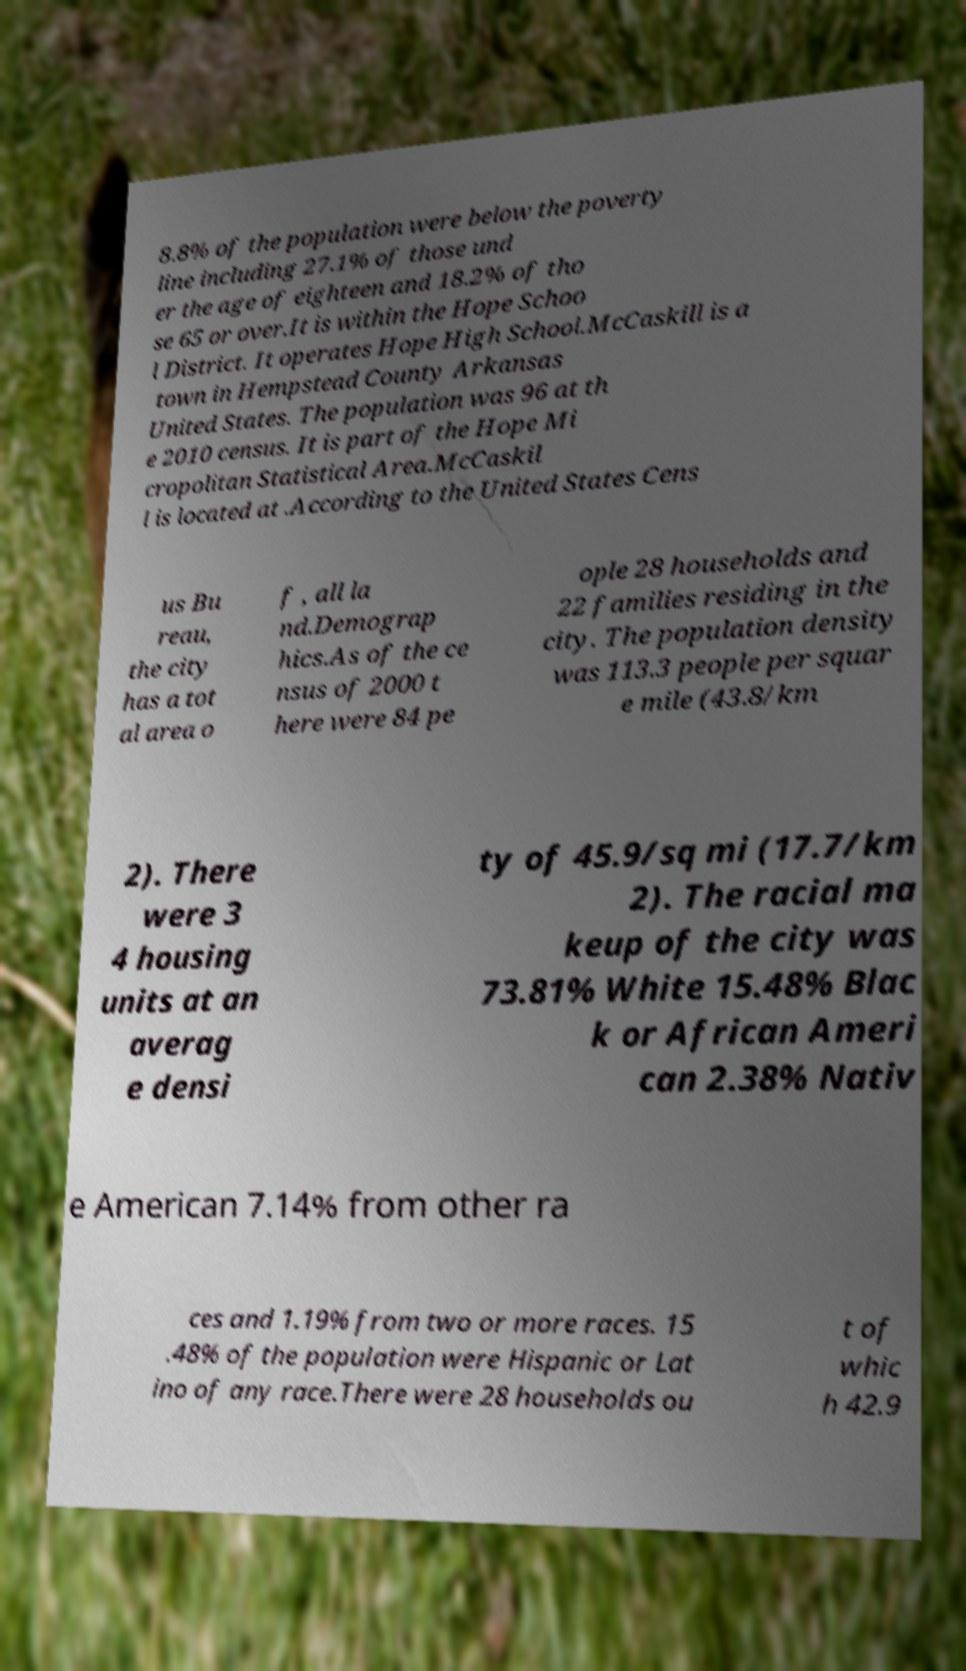Please read and relay the text visible in this image. What does it say? 8.8% of the population were below the poverty line including 27.1% of those und er the age of eighteen and 18.2% of tho se 65 or over.It is within the Hope Schoo l District. It operates Hope High School.McCaskill is a town in Hempstead County Arkansas United States. The population was 96 at th e 2010 census. It is part of the Hope Mi cropolitan Statistical Area.McCaskil l is located at .According to the United States Cens us Bu reau, the city has a tot al area o f , all la nd.Demograp hics.As of the ce nsus of 2000 t here were 84 pe ople 28 households and 22 families residing in the city. The population density was 113.3 people per squar e mile (43.8/km 2). There were 3 4 housing units at an averag e densi ty of 45.9/sq mi (17.7/km 2). The racial ma keup of the city was 73.81% White 15.48% Blac k or African Ameri can 2.38% Nativ e American 7.14% from other ra ces and 1.19% from two or more races. 15 .48% of the population were Hispanic or Lat ino of any race.There were 28 households ou t of whic h 42.9 